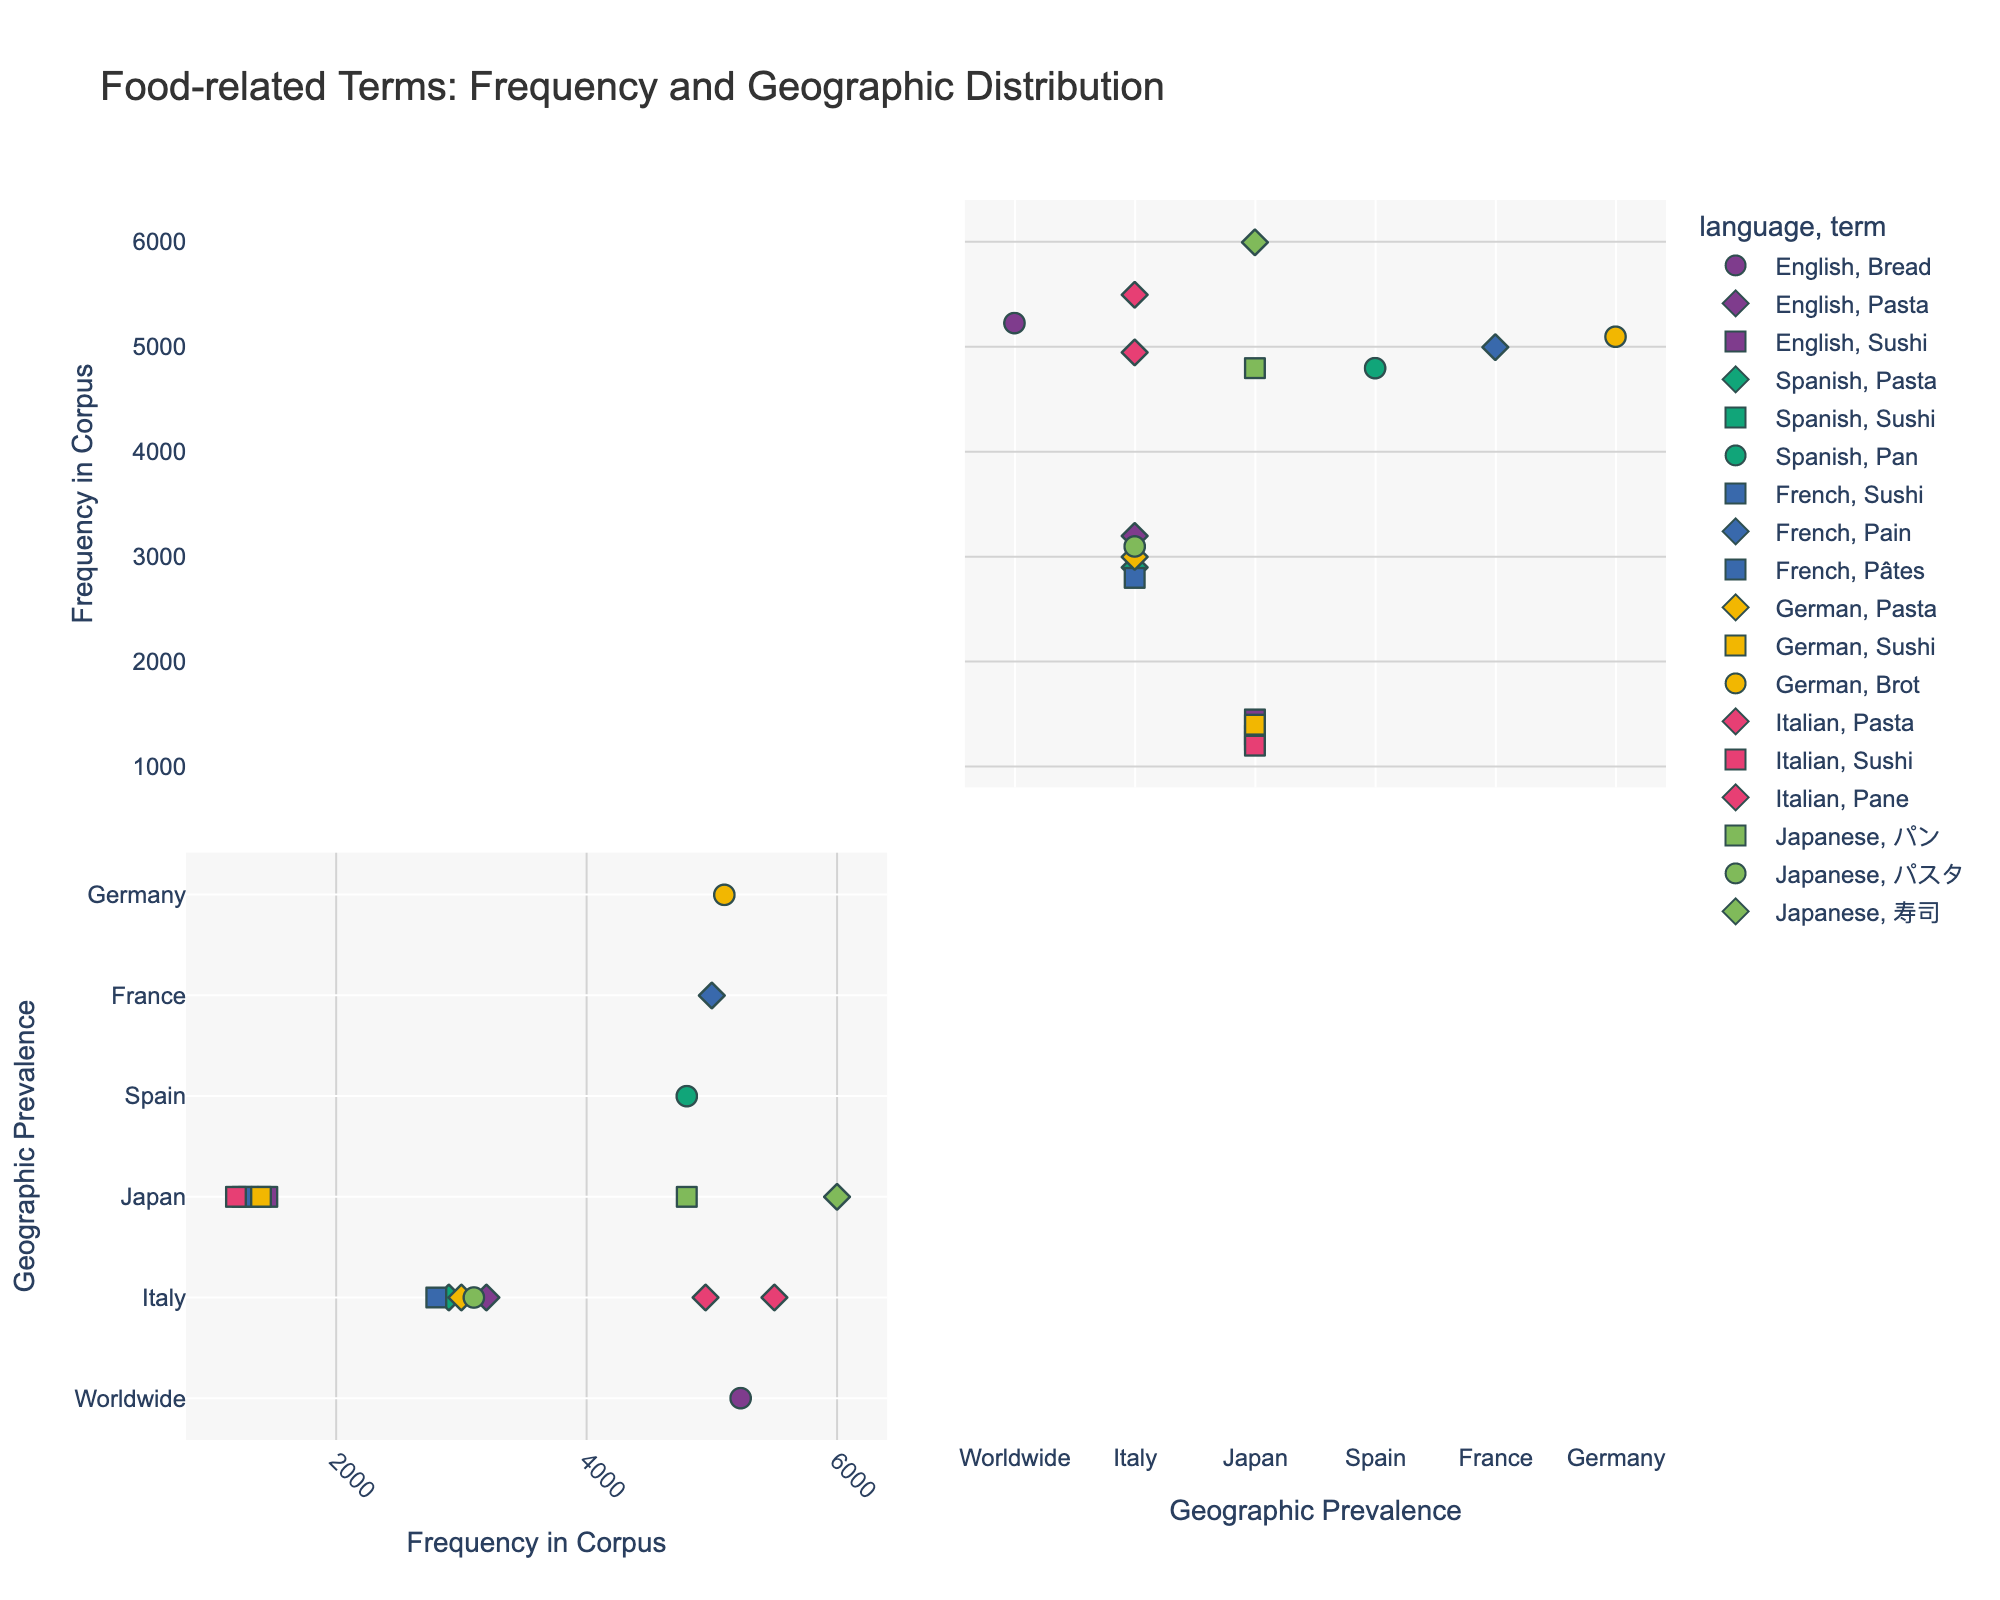What is the title of the visual? The title is usually located at the top of the visual representation.
Answer: Food-related Terms: Frequency and Geographic Distribution Which language has the highest frequency for the term "Sushi"? Look for the "Sushi" symbol across all languages and compare their frequencies in the corpus.
Answer: Japanese How does the frequency of "パン" in Japanese compare to "Pain" in French and "Pan" in Spanish? Refer to the frequency values for each term in the visual and compare them. "パン" is found in Japanese and "Pain" in French and "Pan" in Spanish.
Answer: パン: 4800, Pain: 5000, Pan: 4800 Which term has the highest frequency in the corpus for Italian? Check the data points for terms under the Italian language and compare their frequencies.
Answer: Pasta What is the geographic prevalence of 'Pasta' across all languages? Look at the 'geographic_prevalence' values for 'Pasta' across different languages and note the trend.
Answer: Italy Which language has terms with the most diverse geographic prevalence? Look for the language with the widest spread of data points along the 'geographic_prevalence' axis.
Answer: English Compare the frequency in the corpus for 'Bread' in English versus 'Brot' in German? Identify the data points for 'Bread' in English and 'Brot' in German and compare the heights on the 'freq_in_corpus' axis.
Answer: Bread: 5230, Brot: 5100 What term appears in all languages and how is its frequency distributed across them? Identify the term that is shared among all languages and compare its frequency in the corpus across the languages.
Answer: Sushi, frequencies vary: English: 1450, Spanish: 1300, French: 1250, German: 1400, Italian: 1200, Japanese: 6000 